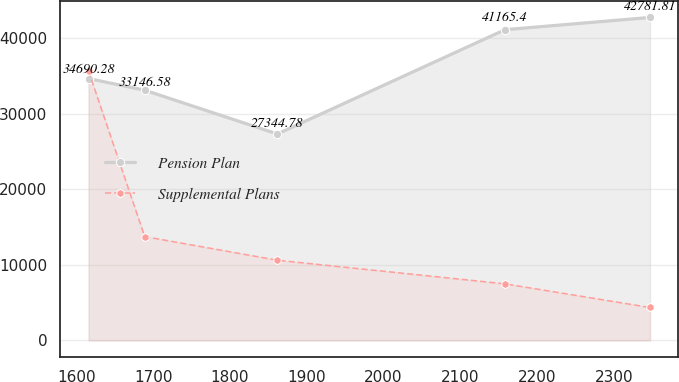Convert chart. <chart><loc_0><loc_0><loc_500><loc_500><line_chart><ecel><fcel>Pension Plan<fcel>Supplemental Plans<nl><fcel>1615.64<fcel>34690.3<fcel>35677.9<nl><fcel>1688.79<fcel>33146.6<fcel>13756.6<nl><fcel>1861.62<fcel>27344.8<fcel>10625<nl><fcel>2158.34<fcel>41165.4<fcel>7493.36<nl><fcel>2347.15<fcel>42781.8<fcel>4361.74<nl></chart> 